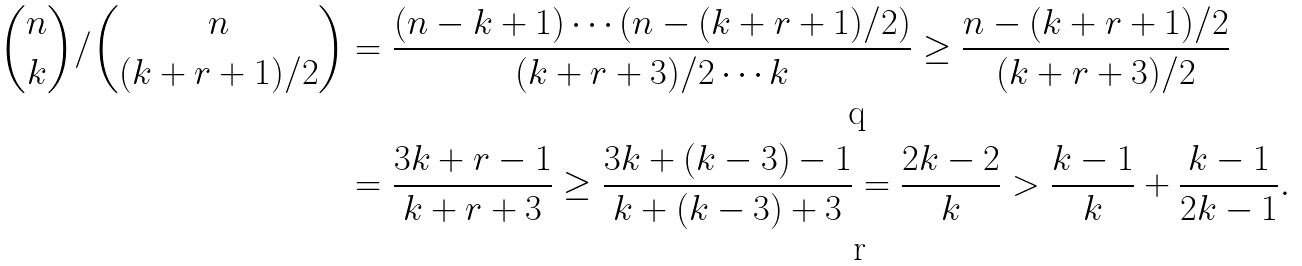Convert formula to latex. <formula><loc_0><loc_0><loc_500><loc_500>\binom { n } { k } / \binom { n } { ( k + r + 1 ) / 2 } & = \frac { ( n - k + 1 ) \cdots ( n - ( k + r + 1 ) / 2 ) } { ( k + r + 3 ) / 2 \cdots k } \geq \frac { n - ( k + r + 1 ) / 2 } { ( k + r + 3 ) / 2 } \\ & = \frac { 3 k + r - 1 } { k + r + 3 } \geq \frac { 3 k + ( k - 3 ) - 1 } { k + ( k - 3 ) + 3 } = \frac { 2 k - 2 } { k } > \frac { k - 1 } { k } + \frac { k - 1 } { 2 k - 1 } .</formula> 